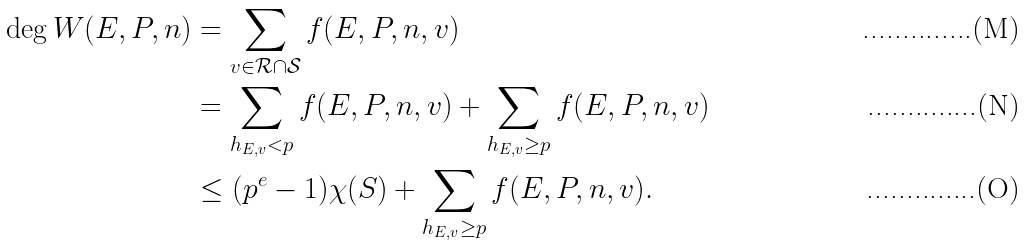<formula> <loc_0><loc_0><loc_500><loc_500>\deg W ( E , P , n ) & = \sum _ { v \in \mathcal { R } \cap \mathcal { S } } f ( E , P , n , v ) \\ & = \sum _ { h _ { E , v } < p } f ( E , P , n , v ) + \sum _ { h _ { E , v } \geq p } f ( E , P , n , v ) \\ & \leq ( p ^ { e } - 1 ) \chi ( S ) + \sum _ { h _ { E , v } \geq p } f ( E , P , n , v ) .</formula> 